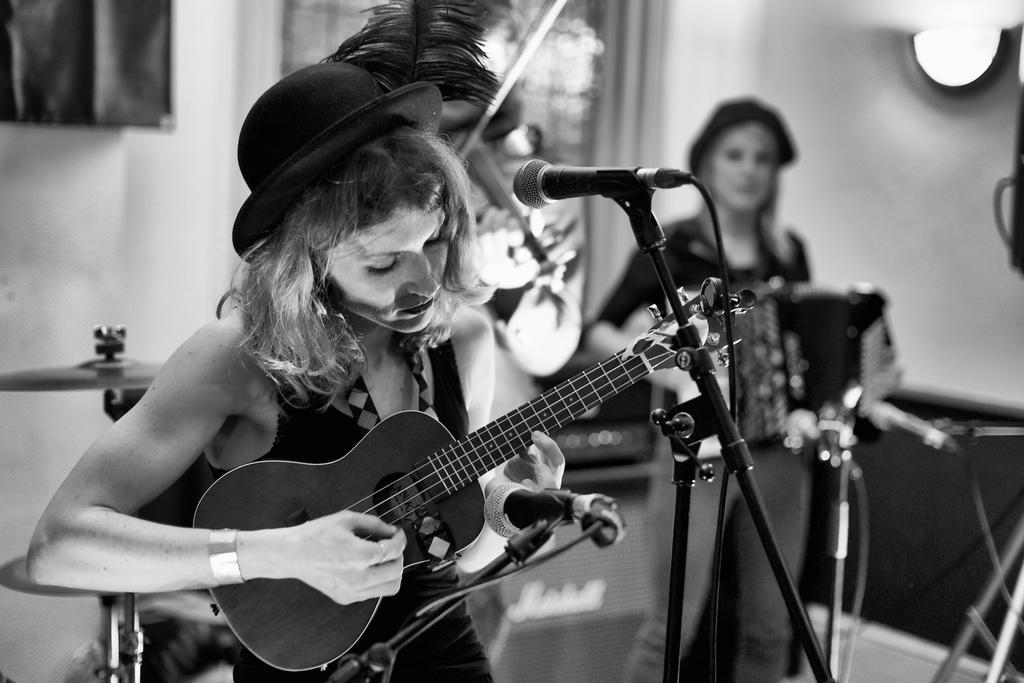Could you give a brief overview of what you see in this image? In this image there are two person in front the woman is playing a guitar at the back side there is a wall. 